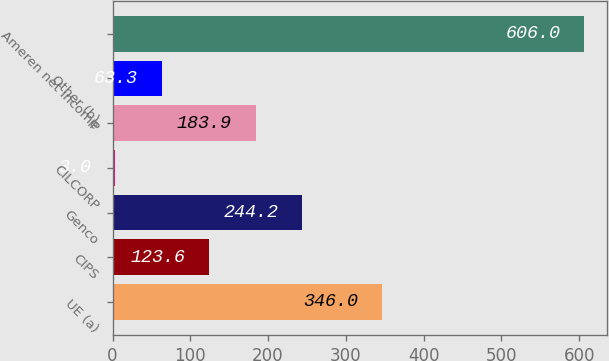Convert chart. <chart><loc_0><loc_0><loc_500><loc_500><bar_chart><fcel>UE (a)<fcel>CIPS<fcel>Genco<fcel>CILCORP<fcel>IP<fcel>Other (b)<fcel>Ameren net income<nl><fcel>346<fcel>123.6<fcel>244.2<fcel>3<fcel>183.9<fcel>63.3<fcel>606<nl></chart> 